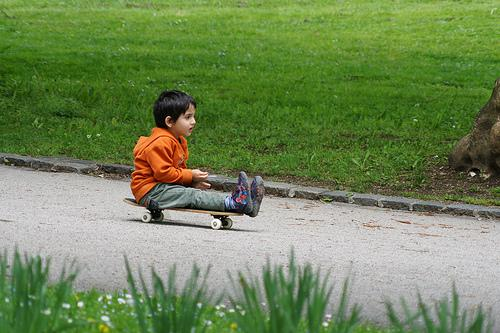Question: what color is the boy's shirt?
Choices:
A. White.
B. Orange.
C. Blue.
D. Red.
Answer with the letter. Answer: B Question: what color is the grass?
Choices:
A. White.
B. Yellow.
C. Brown.
D. Green.
Answer with the letter. Answer: D Question: who is on the skateboard?
Choices:
A. A girl.
B. A man.
C. A boy.
D. A woman.
Answer with the letter. Answer: C 